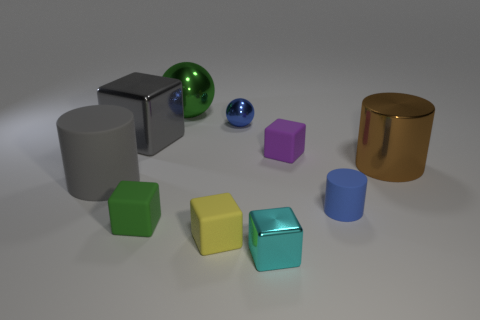Are any red rubber cubes visible?
Your answer should be compact. No. There is a matte thing behind the large shiny object in front of the small purple object; what is its shape?
Make the answer very short. Cube. What number of things are small rubber blocks that are behind the large matte cylinder or things in front of the gray block?
Provide a succinct answer. 7. There is a green block that is the same size as the yellow object; what is it made of?
Make the answer very short. Rubber. The tiny rubber cylinder is what color?
Provide a short and direct response. Blue. What is the material of the block that is both to the right of the yellow matte object and behind the large shiny cylinder?
Keep it short and to the point. Rubber. There is a metallic block to the right of the green object that is in front of the brown object; are there any small yellow rubber cubes in front of it?
Offer a terse response. No. There is a rubber thing that is the same color as the large shiny sphere; what is its size?
Make the answer very short. Small. Are there any small objects to the left of the gray rubber thing?
Provide a succinct answer. No. What number of other objects are the same shape as the small cyan shiny thing?
Offer a terse response. 4. 